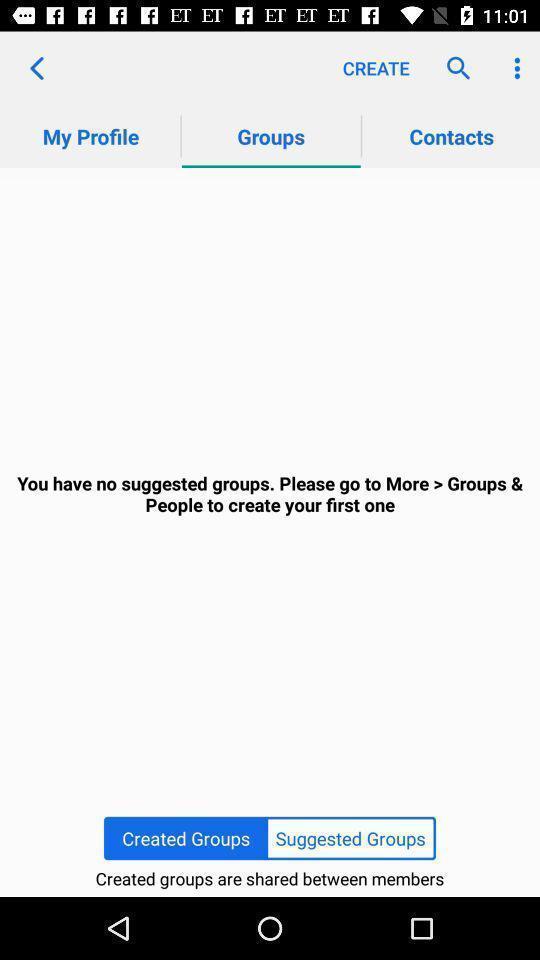What can you discern from this picture? Screen displaying the groups page. 